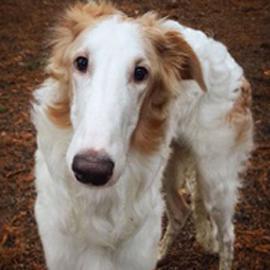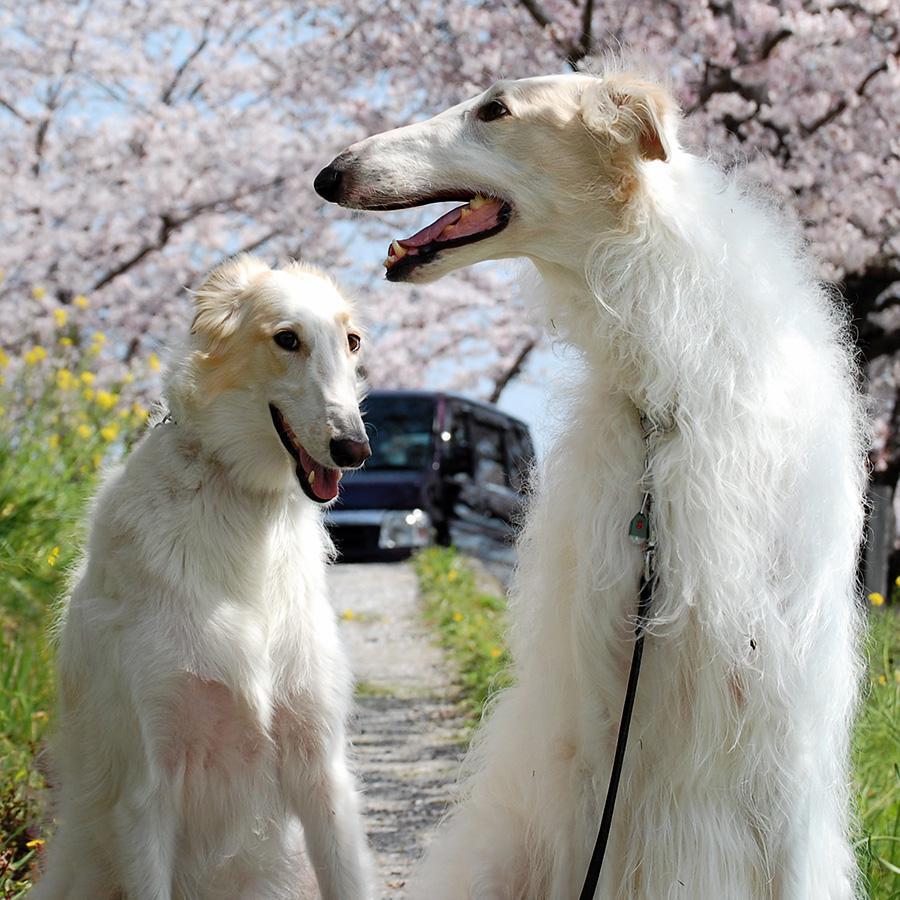The first image is the image on the left, the second image is the image on the right. For the images shown, is this caption "The right image contains one hound standing in profile with its body turned leftward, and the left image contains three hounds with their heads not all pointed in the same direction." true? Answer yes or no. No. The first image is the image on the left, the second image is the image on the right. Considering the images on both sides, is "The left image contains three dogs." valid? Answer yes or no. No. 